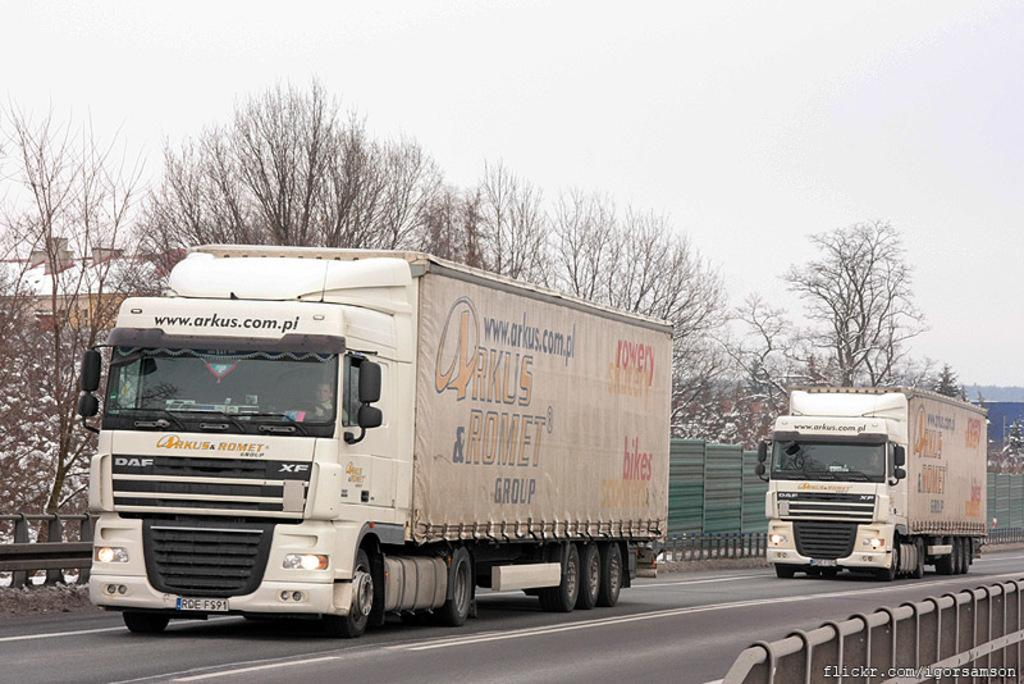What vehicles can be seen on the road in the image? There are two trucks on the road in the image. What is visible in the background of the image? There is a fence and trees in the background of the image. What is visible at the top of the image? The sky is visible at the top of the image. How much money is being exchanged between the trucks in the image? There is no indication of any money exchange between the trucks in the image. What type of quilt is being used to cover the trucks in the image? There are no quilts present in the image; the trucks are not covered. 